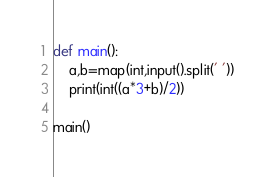Convert code to text. <code><loc_0><loc_0><loc_500><loc_500><_Python_>def main():
    a,b=map(int,input().split(' '))
    print(int((a*3+b)/2))

main()
</code> 